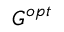Convert formula to latex. <formula><loc_0><loc_0><loc_500><loc_500>G ^ { o p t }</formula> 